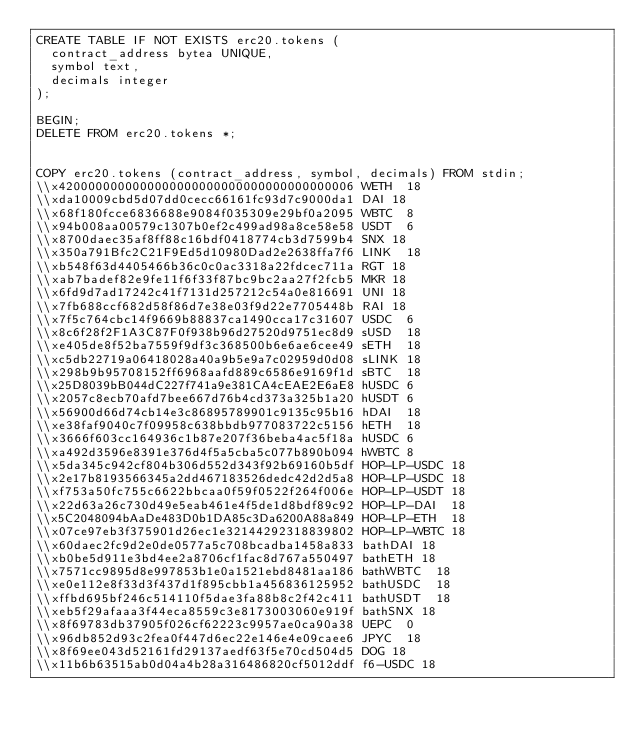Convert code to text. <code><loc_0><loc_0><loc_500><loc_500><_SQL_>CREATE TABLE IF NOT EXISTS erc20.tokens (
	contract_address bytea UNIQUE,
	symbol text,
	decimals integer
);

BEGIN;
DELETE FROM erc20.tokens *;


COPY erc20.tokens (contract_address, symbol, decimals) FROM stdin;
\\x4200000000000000000000000000000000000006	WETH	18
\\xda10009cbd5d07dd0cecc66161fc93d7c9000da1	DAI	18
\\x68f180fcce6836688e9084f035309e29bf0a2095	WBTC	8
\\x94b008aa00579c1307b0ef2c499ad98a8ce58e58	USDT	6
\\x8700daec35af8ff88c16bdf0418774cb3d7599b4	SNX	18
\\x350a791Bfc2C21F9Ed5d10980Dad2e2638ffa7f6	LINK	18
\\xb548f63d4405466b36c0c0ac3318a22fdcec711a	RGT	18
\\xab7badef82e9fe11f6f33f87bc9bc2aa27f2fcb5	MKR	18
\\x6fd9d7ad17242c41f7131d257212c54a0e816691	UNI	18
\\x7fb688ccf682d58f86d7e38e03f9d22e7705448b	RAI	18
\\x7f5c764cbc14f9669b88837ca1490cca17c31607	USDC	6
\\x8c6f28f2F1A3C87F0f938b96d27520d9751ec8d9	sUSD	18
\\xe405de8f52ba7559f9df3c368500b6e6ae6cee49	sETH	18
\\xc5db22719a06418028a40a9b5e9a7c02959d0d08	sLINK	18
\\x298b9b95708152ff6968aafd889c6586e9169f1d	sBTC	18
\\x25D8039bB044dC227f741a9e381CA4cEAE2E6aE8	hUSDC	6
\\x2057c8ecb70afd7bee667d76b4cd373a325b1a20	hUSDT	6
\\x56900d66d74cb14e3c86895789901c9135c95b16	hDAI	18
\\xe38faf9040c7f09958c638bbdb977083722c5156	hETH	18
\\x3666f603cc164936c1b87e207f36beba4ac5f18a	hUSDC	6
\\xa492d3596e8391e376d4f5a5cba5c077b890b094	hWBTC	8
\\x5da345c942cf804b306d552d343f92b69160b5df	HOP-LP-USDC	18
\\x2e17b8193566345a2dd467183526dedc42d2d5a8	HOP-LP-USDC	18
\\xf753a50fc755c6622bbcaa0f59f0522f264f006e	HOP-LP-USDT	18
\\x22d63a26c730d49e5eab461e4f5de1d8bdf89c92	HOP-LP-DAI	18
\\x5C2048094bAaDe483D0b1DA85c3Da6200A88a849	HOP-LP-ETH	18
\\x07ce97eb3f375901d26ec1e32144292318839802	HOP-LP-WBTC	18
\\x60daec2fc9d2e0de0577a5c708bcadba1458a833	bathDAI	18
\\xb0be5d911e3bd4ee2a8706cf1fac8d767a550497	bathETH	18
\\x7571cc9895d8e997853b1e0a1521ebd8481aa186	bathWBTC	18
\\xe0e112e8f33d3f437d1f895cbb1a456836125952	bathUSDC	18
\\xffbd695bf246c514110f5dae3fa88b8c2f42c411	bathUSDT	18
\\xeb5f29afaaa3f44eca8559c3e8173003060e919f	bathSNX	18
\\x8f69783db37905f026cf62223c9957ae0ca90a38	UEPC	0
\\x96db852d93c2fea0f447d6ec22e146e4e09caee6	JPYC	18
\\x8f69ee043d52161fd29137aedf63f5e70cd504d5	DOG	18
\\x11b6b63515ab0d04a4b28a316486820cf5012ddf	f6-USDC	18</code> 